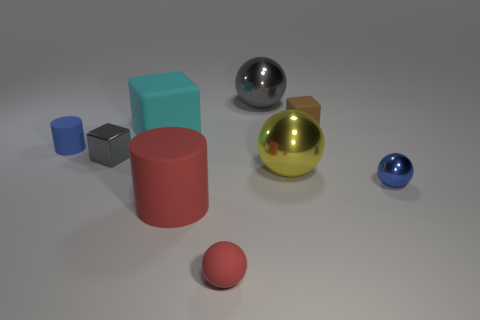What is the shape of the small brown rubber thing?
Make the answer very short. Cube. What number of blue things are behind the big cyan matte object?
Offer a very short reply. 0. What number of gray objects are made of the same material as the blue cylinder?
Your answer should be very brief. 0. Are the tiny block in front of the small brown rubber cube and the big cyan block made of the same material?
Your answer should be compact. No. Is there a small red matte ball?
Offer a terse response. Yes. How big is the metal ball that is on the left side of the tiny brown rubber object and in front of the large rubber block?
Make the answer very short. Large. Is the number of red rubber objects behind the brown block greater than the number of big cyan objects that are in front of the large matte block?
Offer a very short reply. No. What size is the sphere that is the same color as the tiny matte cylinder?
Provide a short and direct response. Small. The big block has what color?
Offer a very short reply. Cyan. What is the color of the thing that is behind the tiny blue rubber thing and right of the yellow thing?
Your answer should be very brief. Brown. 